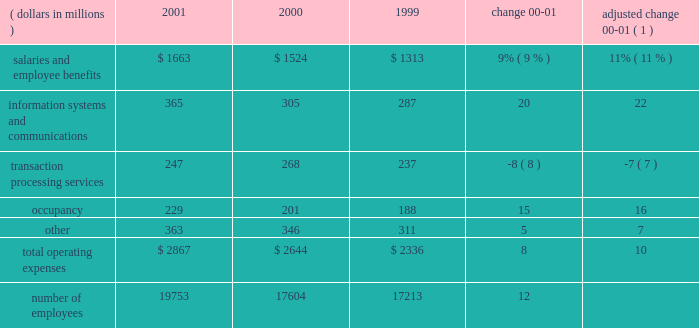Operating expenses operating expenses were $ 2.9 billion , an increase of 8% ( 8 % ) over 2000 .
Adjusted for the formation of citistreet , operating expenses grew 10% ( 10 % ) .
Expense growth in 2001 of 10% ( 10 % ) is significantly lower than the comparable 20% ( 20 % ) expense growth for 2000 compared to 1999 .
State street successfully reduced the growth rate of expenses as revenue growth slowed during the latter half of 2000 and early 2001 .
The expense growth in 2001 reflects higher expenses for salaries and employee benefits , as well as information systems and communications .
O p e r a t i n g e x p e n s e s ( dollars in millions ) 2001 2000 1999 change adjusted change 00-01 ( 1 ) .
( 1 ) 2000 results adjusted for the formation of citistreet expenses related to salaries and employee benefits increased $ 139million in 2001 , or $ 163millionwhen adjusted for the formation of citistreet .
The adjusted increase reflects more than 2100 additional staff to support the large client wins and new business from existing clients and acquisitions .
This expense increase was partially offset by lower incentive-based compensation .
Information systems and communications expense was $ 365 million in 2001 , up 20% ( 20 % ) from the prior year .
Adjusted for the formation of citistreet , information systems and communications expense increased 22% ( 22 % ) .
This growth reflects both continuing investment in software and hardware , aswell as the technology costs associated with increased staffing levels .
Expenses related to transaction processing services were $ 247 million , down $ 21 million , or 8% ( 8 % ) .
These expenses are volume related and include external contract services , subcustodian fees , brokerage services and fees related to securities settlement .
Lower mutual fund shareholder activities , and lower subcustodian fees resulting from both the decline in asset values and lower transaction volumes , drove the decline .
Occupancy expensewas $ 229million , up 15% ( 15 % ) .
The increase is due to expenses necessary to support state street 2019s global growth , and expenses incurred for leasehold improvements and other operational costs .
Other expenses were $ 363 million , up $ 17 million , or 5% ( 5 % ) .
These expenses include professional services , advertising and sales promotion , and internal operational expenses .
The increase over prior year is due to a $ 21 million increase in the amortization of goodwill , primarily from acquisitions in 2001 .
In accordance with recent accounting pronouncements , goodwill amortization expense will be eliminated in 2002 .
State street recorded approximately $ 38 million , or $ .08 per share after tax , of goodwill amortization expense in 2001 .
State street 2019s cost containment efforts , which reduced discretionary spending , partially offset the increase in other expenses .
State street corporation 9 .
What is the growth rate in the number of employees from 2000 to 2001? 
Computations: ((19753 - 17604) / 17604)
Answer: 0.12207. 